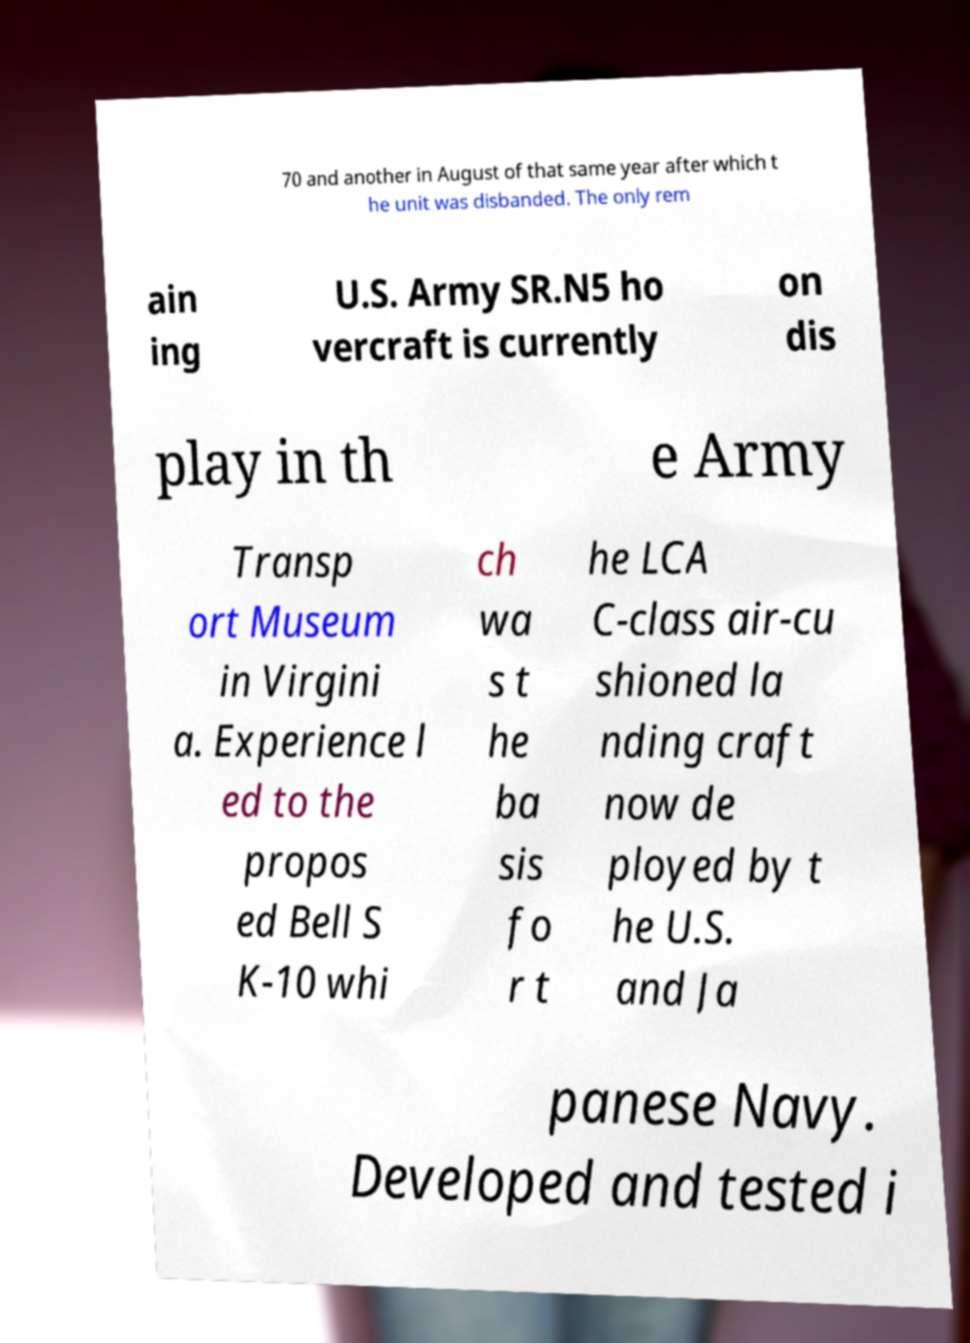Could you assist in decoding the text presented in this image and type it out clearly? 70 and another in August of that same year after which t he unit was disbanded. The only rem ain ing U.S. Army SR.N5 ho vercraft is currently on dis play in th e Army Transp ort Museum in Virgini a. Experience l ed to the propos ed Bell S K-10 whi ch wa s t he ba sis fo r t he LCA C-class air-cu shioned la nding craft now de ployed by t he U.S. and Ja panese Navy. Developed and tested i 